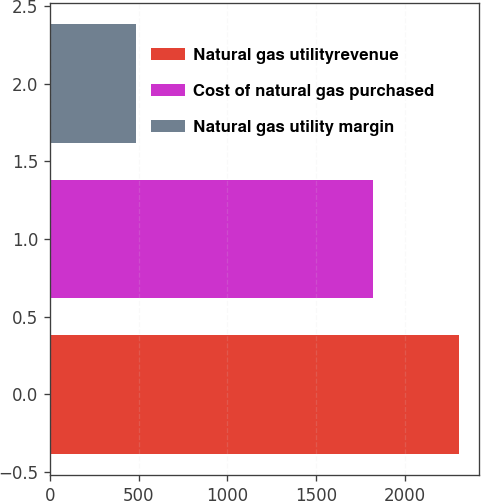<chart> <loc_0><loc_0><loc_500><loc_500><bar_chart><fcel>Natural gas utilityrevenue<fcel>Cost of natural gas purchased<fcel>Natural gas utility margin<nl><fcel>2307<fcel>1823<fcel>484<nl></chart> 